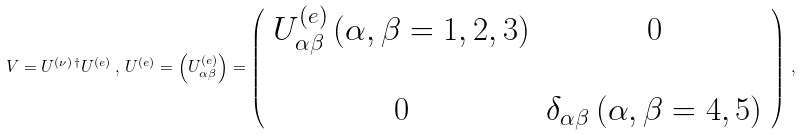<formula> <loc_0><loc_0><loc_500><loc_500>V = U ^ { ( \nu ) \, \dagger } U ^ { ( e ) } \, , \, U ^ { ( e ) } = \left ( U ^ { ( e ) } _ { \alpha \beta } \right ) = \left ( \begin{array} { c c } U ^ { ( e ) } _ { \alpha \beta } \, ( \alpha , \beta = 1 , 2 , 3 ) & 0 \\ & \\ 0 & \delta _ { \alpha \beta } \, ( \alpha , \beta = 4 , 5 ) \end{array} \right ) \, ,</formula> 